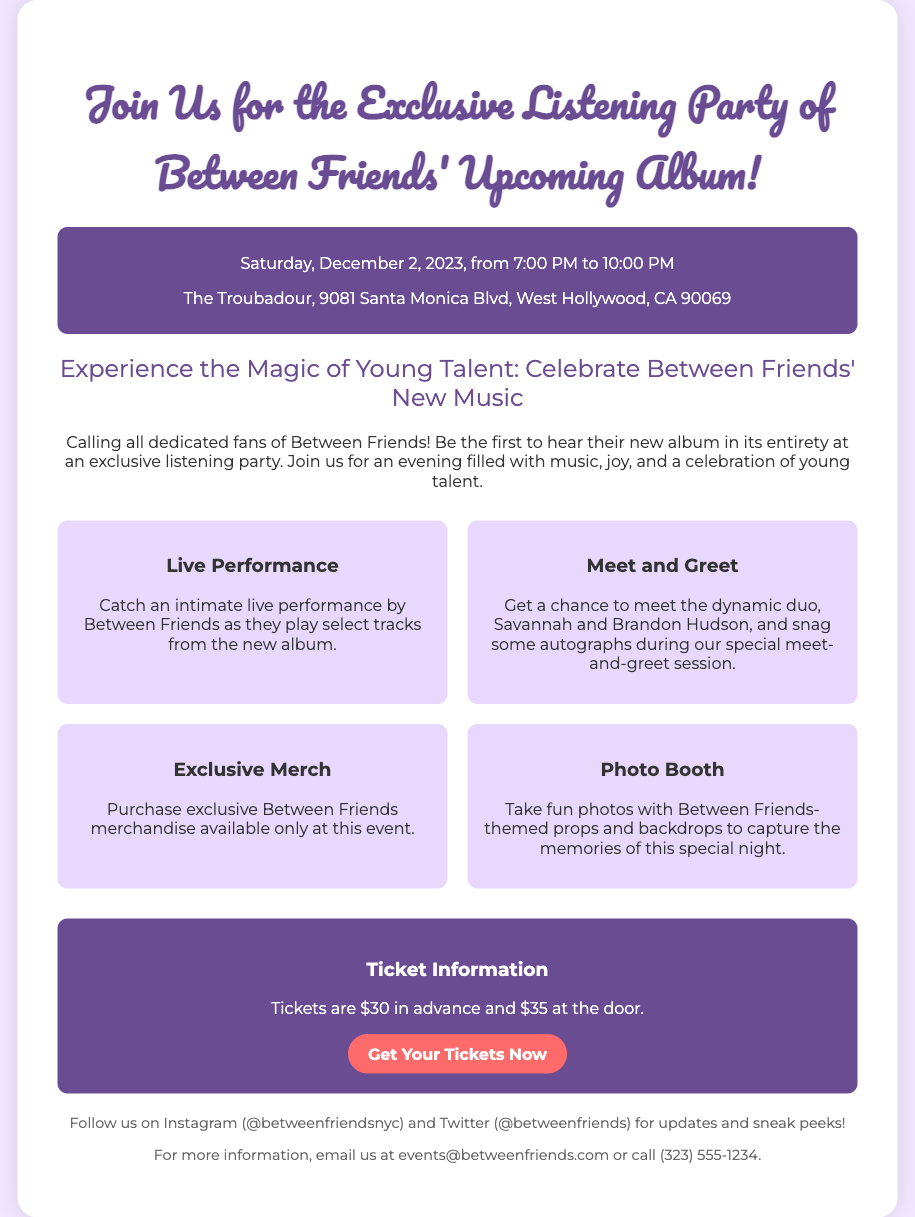What is the date of the album release party? The date mentioned for the album release party is Saturday, December 2, 2023.
Answer: Saturday, December 2, 2023 Where is the event taking place? The venue for the event is The Troubadour, located at 9081 Santa Monica Blvd, West Hollywood, CA 90069.
Answer: The Troubadour, 9081 Santa Monica Blvd, West Hollywood, CA 90069 What is the ticket price at the door? The document states that the ticket price at the door is $35.
Answer: $35 Who are the members of Between Friends? The members mentioned in the document are Savannah and Brandon Hudson.
Answer: Savannah and Brandon Hudson What type of special session is mentioned in the highlights? A meet-and-greet session is highlighted as a special opportunity during the event.
Answer: Meet and Greet How long is the listening party scheduled to last? The listening party is scheduled to last from 7:00 PM to 10:00 PM, which is 3 hours.
Answer: 3 hours What is the main purpose of the event? The main purpose of the event is to provide fans an exclusive opportunity to hear Between Friends' new album in its entirety.
Answer: Exclusive listening party What kind of merchandise will be available at the event? The document states that exclusive Between Friends merchandise will be on sale, available only at this event.
Answer: Exclusive Between Friends merchandise 